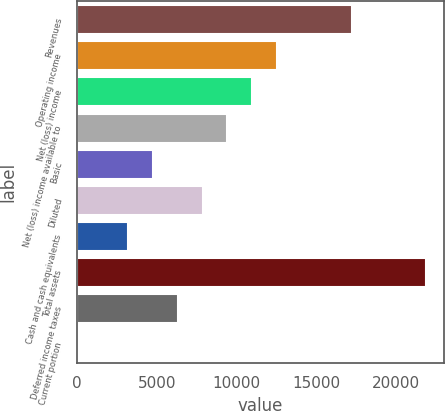<chart> <loc_0><loc_0><loc_500><loc_500><bar_chart><fcel>Revenues<fcel>Operating income<fcel>Net (loss) income<fcel>Net (loss) income available to<fcel>Basic<fcel>Diluted<fcel>Cash and cash equivalents<fcel>Total assets<fcel>Deferred income taxes<fcel>Current portion<nl><fcel>17231<fcel>12554<fcel>10995<fcel>9436<fcel>4759<fcel>7877<fcel>3200<fcel>21908<fcel>6318<fcel>82<nl></chart> 